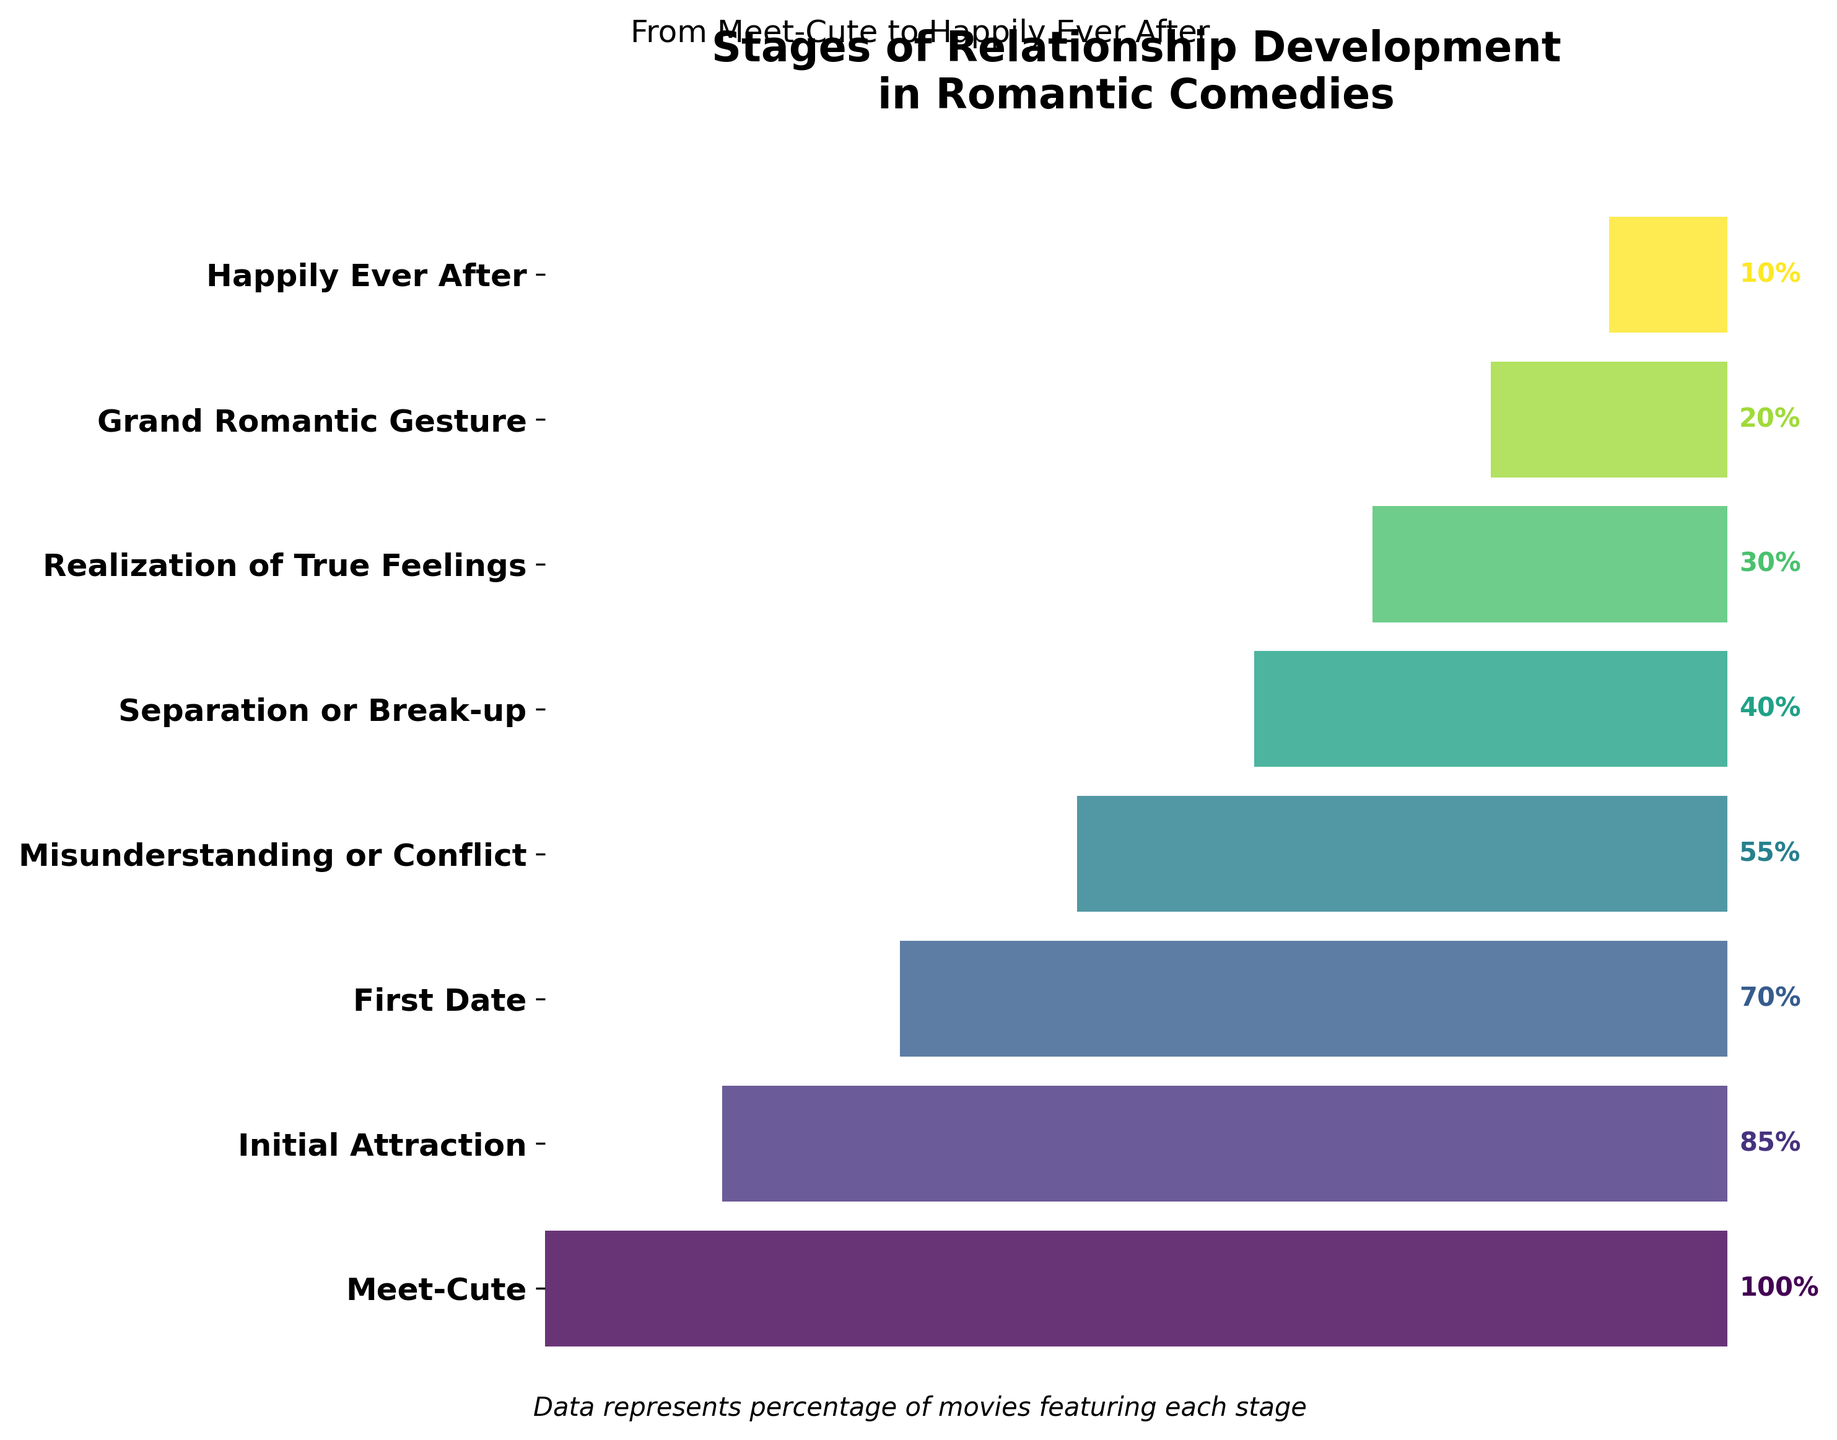what is the title of the figure? The title is usually displayed at the top of the plot and indicates the main topic or information visually represented. In this figure, it's written in bold at the very top.
Answer: Stages of Relationship Development in Romantic Comedies How many stages are depicted in the funnel chart? Count the number of distinct stages listed on the y-axis of the funnel chart.
Answer: 8 Which stage has the highest percentage? Identify the stage with the largest bar length or the highest percentage label.
Answer: Meet-Cute Which stage marks the transition point where the percentage drops below 50%? Look for the stage where the percentage first dips below 50%.
Answer: Misunderstanding or Conflict How does the percentage of "First Date" compare to "Realization of True Feelings"? Compare the length/percentage values between these two stages from the figure.
Answer: "First Date" has a higher percentage than "Realization of True Feelings" What is the percentage drop from "Initial Attraction" to "Separation or Break-up"? Subtract the percentage of "Separation or Break-up" from that of "Initial Attraction".
Answer: 45% How do the percentages change from "Separation or Break-up" to "Grand Romantic Gesture"? Note the percentages associated with these stages and calculate the successive changes.
Answer: The percentage decreases from 40% to 20% Which stage comes directly after "Misunderstanding or Conflict" and what is its percentage? Identify the stage listed immediately after "Misunderstanding or Conflict" and find its percentage from the figure.
Answer: Separation or Break-up, 40% What is the cumulative percentage of all stages from "Realization of True Feelings" to "Happily Ever After"? Add the percentages of the stages starting from "Realization of True Feelings" to the final one.
Answer: 60% What unique aspect does the funnel chart highlight about the progression through stages in romantic comedies? Funnel charts effectively show how the proportion of entities decreases as they move through successive stages, showcasing a clear drop-off from start to finish.
Answer: Progressive decrease in stages 